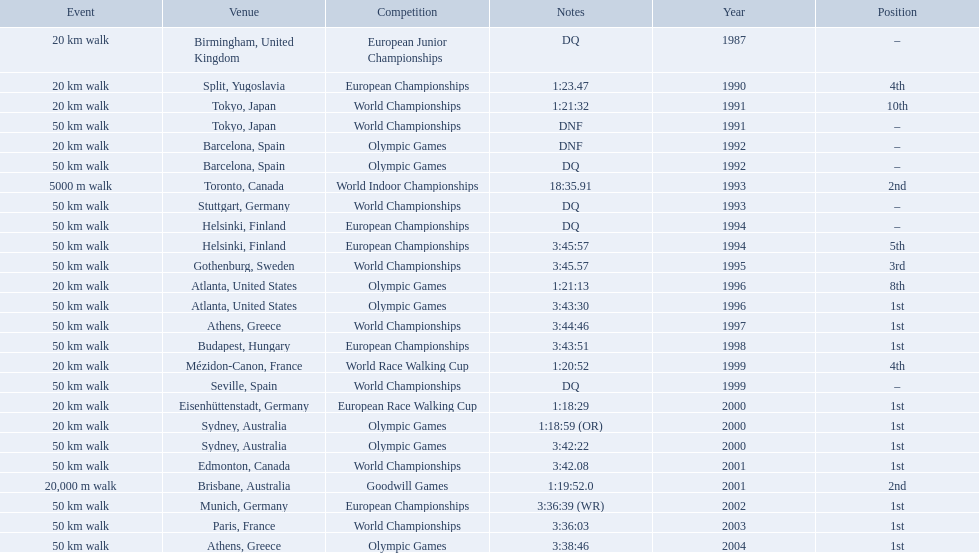In 1990 what position did robert korzeniowski place? 4th. In 1993 what was robert korzeniowski's place in the world indoor championships? 2nd. How long did the 50km walk in 2004 olympic cost? 3:38:46. 